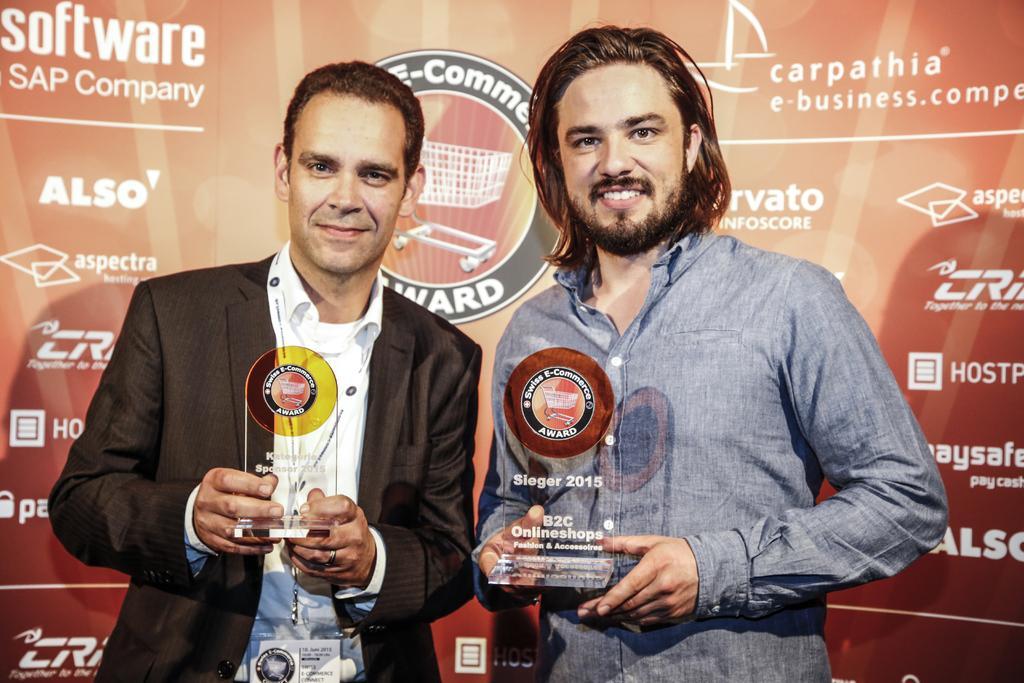Describe this image in one or two sentences. In this picture we can see two people, they are holding trophies and in the background we can see a banner. 